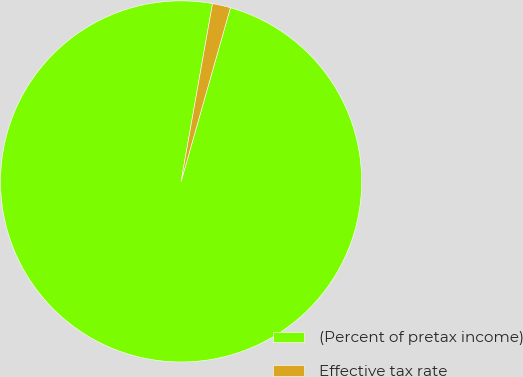Convert chart. <chart><loc_0><loc_0><loc_500><loc_500><pie_chart><fcel>(Percent of pretax income)<fcel>Effective tax rate<nl><fcel>98.38%<fcel>1.62%<nl></chart> 